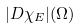<formula> <loc_0><loc_0><loc_500><loc_500>| D \chi _ { E } | ( \Omega )</formula> 